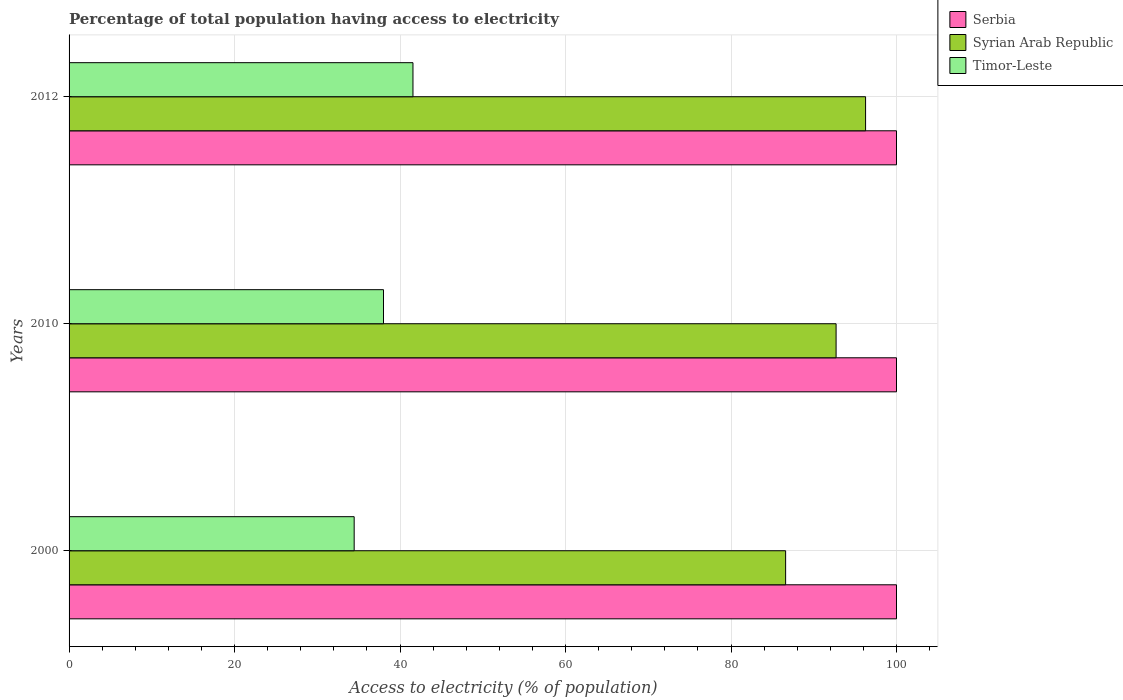How many different coloured bars are there?
Give a very brief answer. 3. Are the number of bars per tick equal to the number of legend labels?
Your answer should be compact. Yes. Are the number of bars on each tick of the Y-axis equal?
Your answer should be compact. Yes. How many bars are there on the 2nd tick from the top?
Provide a short and direct response. 3. In how many cases, is the number of bars for a given year not equal to the number of legend labels?
Keep it short and to the point. 0. What is the percentage of population that have access to electricity in Serbia in 2000?
Your answer should be compact. 100. Across all years, what is the maximum percentage of population that have access to electricity in Syrian Arab Republic?
Provide a short and direct response. 96.26. Across all years, what is the minimum percentage of population that have access to electricity in Serbia?
Your answer should be very brief. 100. What is the total percentage of population that have access to electricity in Syrian Arab Republic in the graph?
Ensure brevity in your answer.  275.56. What is the difference between the percentage of population that have access to electricity in Timor-Leste in 2000 and that in 2012?
Offer a very short reply. -7.11. What is the difference between the percentage of population that have access to electricity in Serbia in 2000 and the percentage of population that have access to electricity in Syrian Arab Republic in 2012?
Your answer should be compact. 3.74. In how many years, is the percentage of population that have access to electricity in Serbia greater than 56 %?
Provide a short and direct response. 3. What is the ratio of the percentage of population that have access to electricity in Serbia in 2000 to that in 2012?
Offer a terse response. 1. What is the difference between the highest and the second highest percentage of population that have access to electricity in Serbia?
Make the answer very short. 0. What is the difference between the highest and the lowest percentage of population that have access to electricity in Timor-Leste?
Keep it short and to the point. 7.11. In how many years, is the percentage of population that have access to electricity in Timor-Leste greater than the average percentage of population that have access to electricity in Timor-Leste taken over all years?
Keep it short and to the point. 1. What does the 3rd bar from the top in 2010 represents?
Provide a short and direct response. Serbia. What does the 2nd bar from the bottom in 2000 represents?
Give a very brief answer. Syrian Arab Republic. Are all the bars in the graph horizontal?
Provide a succinct answer. Yes. Are the values on the major ticks of X-axis written in scientific E-notation?
Provide a short and direct response. No. Does the graph contain any zero values?
Offer a terse response. No. Where does the legend appear in the graph?
Your answer should be compact. Top right. What is the title of the graph?
Make the answer very short. Percentage of total population having access to electricity. Does "Dominican Republic" appear as one of the legend labels in the graph?
Give a very brief answer. No. What is the label or title of the X-axis?
Your answer should be very brief. Access to electricity (% of population). What is the Access to electricity (% of population) in Syrian Arab Republic in 2000?
Provide a short and direct response. 86.6. What is the Access to electricity (% of population) of Timor-Leste in 2000?
Your answer should be very brief. 34.46. What is the Access to electricity (% of population) in Syrian Arab Republic in 2010?
Give a very brief answer. 92.7. What is the Access to electricity (% of population) of Timor-Leste in 2010?
Your response must be concise. 38. What is the Access to electricity (% of population) of Syrian Arab Republic in 2012?
Provide a short and direct response. 96.26. What is the Access to electricity (% of population) in Timor-Leste in 2012?
Offer a terse response. 41.56. Across all years, what is the maximum Access to electricity (% of population) in Serbia?
Your answer should be very brief. 100. Across all years, what is the maximum Access to electricity (% of population) in Syrian Arab Republic?
Your answer should be very brief. 96.26. Across all years, what is the maximum Access to electricity (% of population) in Timor-Leste?
Your answer should be very brief. 41.56. Across all years, what is the minimum Access to electricity (% of population) of Syrian Arab Republic?
Provide a succinct answer. 86.6. Across all years, what is the minimum Access to electricity (% of population) in Timor-Leste?
Provide a succinct answer. 34.46. What is the total Access to electricity (% of population) in Serbia in the graph?
Your response must be concise. 300. What is the total Access to electricity (% of population) in Syrian Arab Republic in the graph?
Keep it short and to the point. 275.56. What is the total Access to electricity (% of population) of Timor-Leste in the graph?
Give a very brief answer. 114.02. What is the difference between the Access to electricity (% of population) of Serbia in 2000 and that in 2010?
Make the answer very short. 0. What is the difference between the Access to electricity (% of population) of Syrian Arab Republic in 2000 and that in 2010?
Your response must be concise. -6.1. What is the difference between the Access to electricity (% of population) of Timor-Leste in 2000 and that in 2010?
Your answer should be compact. -3.54. What is the difference between the Access to electricity (% of population) of Syrian Arab Republic in 2000 and that in 2012?
Your answer should be very brief. -9.66. What is the difference between the Access to electricity (% of population) of Timor-Leste in 2000 and that in 2012?
Provide a short and direct response. -7.11. What is the difference between the Access to electricity (% of population) of Syrian Arab Republic in 2010 and that in 2012?
Give a very brief answer. -3.56. What is the difference between the Access to electricity (% of population) in Timor-Leste in 2010 and that in 2012?
Keep it short and to the point. -3.56. What is the difference between the Access to electricity (% of population) in Serbia in 2000 and the Access to electricity (% of population) in Syrian Arab Republic in 2010?
Offer a very short reply. 7.3. What is the difference between the Access to electricity (% of population) of Serbia in 2000 and the Access to electricity (% of population) of Timor-Leste in 2010?
Give a very brief answer. 62. What is the difference between the Access to electricity (% of population) in Syrian Arab Republic in 2000 and the Access to electricity (% of population) in Timor-Leste in 2010?
Your answer should be very brief. 48.6. What is the difference between the Access to electricity (% of population) in Serbia in 2000 and the Access to electricity (% of population) in Syrian Arab Republic in 2012?
Your answer should be very brief. 3.74. What is the difference between the Access to electricity (% of population) of Serbia in 2000 and the Access to electricity (% of population) of Timor-Leste in 2012?
Ensure brevity in your answer.  58.44. What is the difference between the Access to electricity (% of population) in Syrian Arab Republic in 2000 and the Access to electricity (% of population) in Timor-Leste in 2012?
Give a very brief answer. 45.04. What is the difference between the Access to electricity (% of population) of Serbia in 2010 and the Access to electricity (% of population) of Syrian Arab Republic in 2012?
Offer a very short reply. 3.74. What is the difference between the Access to electricity (% of population) in Serbia in 2010 and the Access to electricity (% of population) in Timor-Leste in 2012?
Keep it short and to the point. 58.44. What is the difference between the Access to electricity (% of population) in Syrian Arab Republic in 2010 and the Access to electricity (% of population) in Timor-Leste in 2012?
Give a very brief answer. 51.14. What is the average Access to electricity (% of population) of Syrian Arab Republic per year?
Keep it short and to the point. 91.85. What is the average Access to electricity (% of population) of Timor-Leste per year?
Offer a very short reply. 38.01. In the year 2000, what is the difference between the Access to electricity (% of population) in Serbia and Access to electricity (% of population) in Timor-Leste?
Ensure brevity in your answer.  65.54. In the year 2000, what is the difference between the Access to electricity (% of population) in Syrian Arab Republic and Access to electricity (% of population) in Timor-Leste?
Offer a terse response. 52.14. In the year 2010, what is the difference between the Access to electricity (% of population) of Syrian Arab Republic and Access to electricity (% of population) of Timor-Leste?
Your response must be concise. 54.7. In the year 2012, what is the difference between the Access to electricity (% of population) in Serbia and Access to electricity (% of population) in Syrian Arab Republic?
Your answer should be compact. 3.74. In the year 2012, what is the difference between the Access to electricity (% of population) in Serbia and Access to electricity (% of population) in Timor-Leste?
Your answer should be compact. 58.44. In the year 2012, what is the difference between the Access to electricity (% of population) in Syrian Arab Republic and Access to electricity (% of population) in Timor-Leste?
Offer a very short reply. 54.7. What is the ratio of the Access to electricity (% of population) of Syrian Arab Republic in 2000 to that in 2010?
Your response must be concise. 0.93. What is the ratio of the Access to electricity (% of population) in Timor-Leste in 2000 to that in 2010?
Offer a terse response. 0.91. What is the ratio of the Access to electricity (% of population) of Serbia in 2000 to that in 2012?
Ensure brevity in your answer.  1. What is the ratio of the Access to electricity (% of population) in Syrian Arab Republic in 2000 to that in 2012?
Provide a short and direct response. 0.9. What is the ratio of the Access to electricity (% of population) in Timor-Leste in 2000 to that in 2012?
Ensure brevity in your answer.  0.83. What is the ratio of the Access to electricity (% of population) in Serbia in 2010 to that in 2012?
Your answer should be compact. 1. What is the ratio of the Access to electricity (% of population) of Syrian Arab Republic in 2010 to that in 2012?
Make the answer very short. 0.96. What is the ratio of the Access to electricity (% of population) of Timor-Leste in 2010 to that in 2012?
Your answer should be compact. 0.91. What is the difference between the highest and the second highest Access to electricity (% of population) of Syrian Arab Republic?
Offer a very short reply. 3.56. What is the difference between the highest and the second highest Access to electricity (% of population) of Timor-Leste?
Your answer should be compact. 3.56. What is the difference between the highest and the lowest Access to electricity (% of population) in Serbia?
Ensure brevity in your answer.  0. What is the difference between the highest and the lowest Access to electricity (% of population) of Syrian Arab Republic?
Your answer should be compact. 9.66. What is the difference between the highest and the lowest Access to electricity (% of population) of Timor-Leste?
Your answer should be compact. 7.11. 